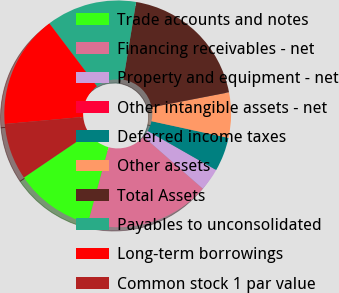<chart> <loc_0><loc_0><loc_500><loc_500><pie_chart><fcel>Trade accounts and notes<fcel>Financing receivables - net<fcel>Property and equipment - net<fcel>Other intangible assets - net<fcel>Deferred income taxes<fcel>Other assets<fcel>Total Assets<fcel>Payables to unconsolidated<fcel>Long-term borrowings<fcel>Common stock 1 par value<nl><fcel>11.29%<fcel>17.74%<fcel>3.23%<fcel>0.0%<fcel>4.84%<fcel>6.45%<fcel>19.35%<fcel>12.9%<fcel>16.13%<fcel>8.06%<nl></chart> 